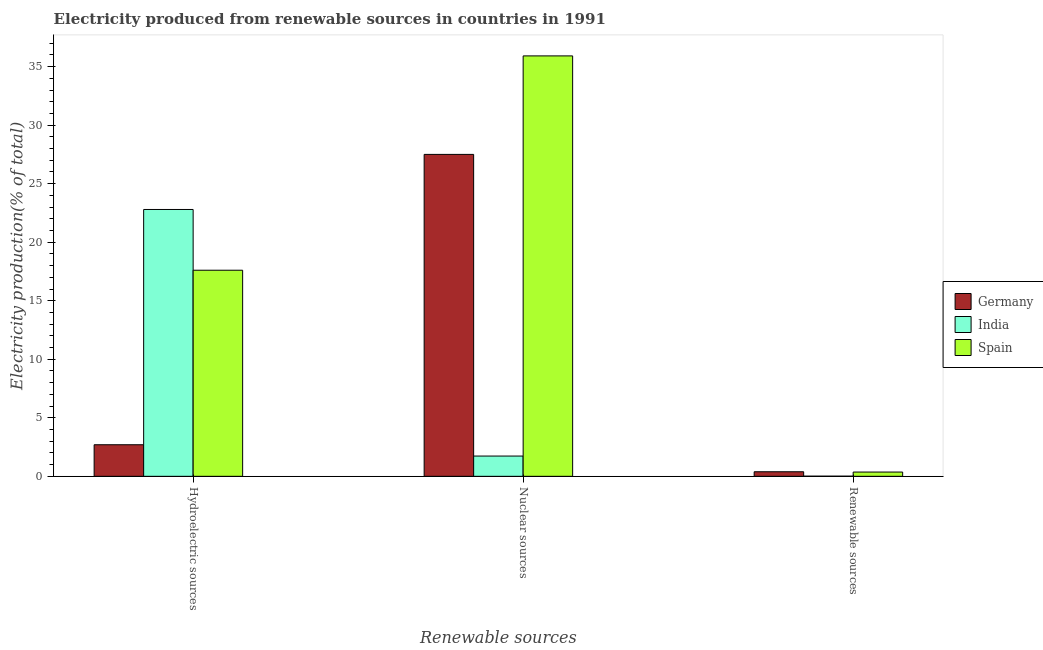Are the number of bars on each tick of the X-axis equal?
Provide a succinct answer. Yes. How many bars are there on the 1st tick from the left?
Your response must be concise. 3. How many bars are there on the 1st tick from the right?
Your answer should be compact. 3. What is the label of the 2nd group of bars from the left?
Make the answer very short. Nuclear sources. What is the percentage of electricity produced by nuclear sources in Spain?
Your answer should be compact. 35.91. Across all countries, what is the maximum percentage of electricity produced by renewable sources?
Provide a short and direct response. 0.39. Across all countries, what is the minimum percentage of electricity produced by hydroelectric sources?
Give a very brief answer. 2.7. In which country was the percentage of electricity produced by nuclear sources maximum?
Give a very brief answer. Spain. In which country was the percentage of electricity produced by hydroelectric sources minimum?
Provide a short and direct response. Germany. What is the total percentage of electricity produced by renewable sources in the graph?
Your answer should be very brief. 0.77. What is the difference between the percentage of electricity produced by nuclear sources in India and that in Spain?
Your answer should be very brief. -34.18. What is the difference between the percentage of electricity produced by nuclear sources in India and the percentage of electricity produced by hydroelectric sources in Germany?
Offer a terse response. -0.97. What is the average percentage of electricity produced by nuclear sources per country?
Your answer should be very brief. 21.72. What is the difference between the percentage of electricity produced by nuclear sources and percentage of electricity produced by renewable sources in Germany?
Provide a succinct answer. 27.11. What is the ratio of the percentage of electricity produced by hydroelectric sources in Germany to that in Spain?
Offer a terse response. 0.15. What is the difference between the highest and the second highest percentage of electricity produced by nuclear sources?
Make the answer very short. 8.41. What is the difference between the highest and the lowest percentage of electricity produced by renewable sources?
Your answer should be very brief. 0.38. Is the sum of the percentage of electricity produced by hydroelectric sources in Spain and Germany greater than the maximum percentage of electricity produced by nuclear sources across all countries?
Ensure brevity in your answer.  No. What does the 3rd bar from the left in Hydroelectric sources represents?
Your response must be concise. Spain. Are all the bars in the graph horizontal?
Your answer should be compact. No. How many legend labels are there?
Offer a very short reply. 3. What is the title of the graph?
Ensure brevity in your answer.  Electricity produced from renewable sources in countries in 1991. What is the label or title of the X-axis?
Give a very brief answer. Renewable sources. What is the Electricity production(% of total) of Germany in Hydroelectric sources?
Your answer should be very brief. 2.7. What is the Electricity production(% of total) of India in Hydroelectric sources?
Offer a very short reply. 22.8. What is the Electricity production(% of total) in Spain in Hydroelectric sources?
Your response must be concise. 17.61. What is the Electricity production(% of total) in Germany in Nuclear sources?
Make the answer very short. 27.5. What is the Electricity production(% of total) in India in Nuclear sources?
Offer a terse response. 1.73. What is the Electricity production(% of total) in Spain in Nuclear sources?
Your answer should be very brief. 35.91. What is the Electricity production(% of total) of Germany in Renewable sources?
Your answer should be very brief. 0.39. What is the Electricity production(% of total) in India in Renewable sources?
Give a very brief answer. 0.01. What is the Electricity production(% of total) in Spain in Renewable sources?
Your response must be concise. 0.36. Across all Renewable sources, what is the maximum Electricity production(% of total) in Germany?
Make the answer very short. 27.5. Across all Renewable sources, what is the maximum Electricity production(% of total) of India?
Make the answer very short. 22.8. Across all Renewable sources, what is the maximum Electricity production(% of total) of Spain?
Your answer should be compact. 35.91. Across all Renewable sources, what is the minimum Electricity production(% of total) of Germany?
Your answer should be very brief. 0.39. Across all Renewable sources, what is the minimum Electricity production(% of total) in India?
Offer a terse response. 0.01. Across all Renewable sources, what is the minimum Electricity production(% of total) in Spain?
Give a very brief answer. 0.36. What is the total Electricity production(% of total) of Germany in the graph?
Provide a succinct answer. 30.59. What is the total Electricity production(% of total) in India in the graph?
Offer a very short reply. 24.54. What is the total Electricity production(% of total) of Spain in the graph?
Your response must be concise. 53.89. What is the difference between the Electricity production(% of total) of Germany in Hydroelectric sources and that in Nuclear sources?
Your response must be concise. -24.8. What is the difference between the Electricity production(% of total) in India in Hydroelectric sources and that in Nuclear sources?
Offer a terse response. 21.06. What is the difference between the Electricity production(% of total) in Spain in Hydroelectric sources and that in Nuclear sources?
Provide a short and direct response. -18.31. What is the difference between the Electricity production(% of total) of Germany in Hydroelectric sources and that in Renewable sources?
Your answer should be compact. 2.31. What is the difference between the Electricity production(% of total) in India in Hydroelectric sources and that in Renewable sources?
Provide a succinct answer. 22.78. What is the difference between the Electricity production(% of total) in Spain in Hydroelectric sources and that in Renewable sources?
Provide a succinct answer. 17.24. What is the difference between the Electricity production(% of total) in Germany in Nuclear sources and that in Renewable sources?
Provide a succinct answer. 27.11. What is the difference between the Electricity production(% of total) in India in Nuclear sources and that in Renewable sources?
Your answer should be very brief. 1.72. What is the difference between the Electricity production(% of total) in Spain in Nuclear sources and that in Renewable sources?
Offer a very short reply. 35.55. What is the difference between the Electricity production(% of total) of Germany in Hydroelectric sources and the Electricity production(% of total) of India in Nuclear sources?
Your answer should be compact. 0.97. What is the difference between the Electricity production(% of total) in Germany in Hydroelectric sources and the Electricity production(% of total) in Spain in Nuclear sources?
Keep it short and to the point. -33.22. What is the difference between the Electricity production(% of total) in India in Hydroelectric sources and the Electricity production(% of total) in Spain in Nuclear sources?
Make the answer very short. -13.12. What is the difference between the Electricity production(% of total) in Germany in Hydroelectric sources and the Electricity production(% of total) in India in Renewable sources?
Your response must be concise. 2.69. What is the difference between the Electricity production(% of total) in Germany in Hydroelectric sources and the Electricity production(% of total) in Spain in Renewable sources?
Provide a succinct answer. 2.33. What is the difference between the Electricity production(% of total) of India in Hydroelectric sources and the Electricity production(% of total) of Spain in Renewable sources?
Provide a succinct answer. 22.43. What is the difference between the Electricity production(% of total) in Germany in Nuclear sources and the Electricity production(% of total) in India in Renewable sources?
Ensure brevity in your answer.  27.49. What is the difference between the Electricity production(% of total) in Germany in Nuclear sources and the Electricity production(% of total) in Spain in Renewable sources?
Offer a very short reply. 27.14. What is the difference between the Electricity production(% of total) of India in Nuclear sources and the Electricity production(% of total) of Spain in Renewable sources?
Your response must be concise. 1.37. What is the average Electricity production(% of total) in Germany per Renewable sources?
Provide a succinct answer. 10.2. What is the average Electricity production(% of total) in India per Renewable sources?
Your response must be concise. 8.18. What is the average Electricity production(% of total) in Spain per Renewable sources?
Offer a very short reply. 17.96. What is the difference between the Electricity production(% of total) of Germany and Electricity production(% of total) of India in Hydroelectric sources?
Make the answer very short. -20.1. What is the difference between the Electricity production(% of total) in Germany and Electricity production(% of total) in Spain in Hydroelectric sources?
Your answer should be very brief. -14.91. What is the difference between the Electricity production(% of total) in India and Electricity production(% of total) in Spain in Hydroelectric sources?
Your answer should be very brief. 5.19. What is the difference between the Electricity production(% of total) in Germany and Electricity production(% of total) in India in Nuclear sources?
Keep it short and to the point. 25.77. What is the difference between the Electricity production(% of total) of Germany and Electricity production(% of total) of Spain in Nuclear sources?
Provide a succinct answer. -8.41. What is the difference between the Electricity production(% of total) in India and Electricity production(% of total) in Spain in Nuclear sources?
Your answer should be very brief. -34.18. What is the difference between the Electricity production(% of total) in Germany and Electricity production(% of total) in India in Renewable sources?
Give a very brief answer. 0.38. What is the difference between the Electricity production(% of total) in Germany and Electricity production(% of total) in Spain in Renewable sources?
Provide a short and direct response. 0.03. What is the difference between the Electricity production(% of total) in India and Electricity production(% of total) in Spain in Renewable sources?
Offer a terse response. -0.35. What is the ratio of the Electricity production(% of total) in Germany in Hydroelectric sources to that in Nuclear sources?
Give a very brief answer. 0.1. What is the ratio of the Electricity production(% of total) in India in Hydroelectric sources to that in Nuclear sources?
Offer a very short reply. 13.17. What is the ratio of the Electricity production(% of total) in Spain in Hydroelectric sources to that in Nuclear sources?
Offer a terse response. 0.49. What is the ratio of the Electricity production(% of total) of Germany in Hydroelectric sources to that in Renewable sources?
Provide a succinct answer. 6.92. What is the ratio of the Electricity production(% of total) in India in Hydroelectric sources to that in Renewable sources?
Ensure brevity in your answer.  1866.03. What is the ratio of the Electricity production(% of total) in Spain in Hydroelectric sources to that in Renewable sources?
Provide a succinct answer. 48.31. What is the ratio of the Electricity production(% of total) in Germany in Nuclear sources to that in Renewable sources?
Offer a very short reply. 70.51. What is the ratio of the Electricity production(% of total) in India in Nuclear sources to that in Renewable sources?
Ensure brevity in your answer.  141.67. What is the ratio of the Electricity production(% of total) in Spain in Nuclear sources to that in Renewable sources?
Your response must be concise. 98.54. What is the difference between the highest and the second highest Electricity production(% of total) in Germany?
Ensure brevity in your answer.  24.8. What is the difference between the highest and the second highest Electricity production(% of total) in India?
Your response must be concise. 21.06. What is the difference between the highest and the second highest Electricity production(% of total) of Spain?
Give a very brief answer. 18.31. What is the difference between the highest and the lowest Electricity production(% of total) of Germany?
Ensure brevity in your answer.  27.11. What is the difference between the highest and the lowest Electricity production(% of total) of India?
Give a very brief answer. 22.78. What is the difference between the highest and the lowest Electricity production(% of total) in Spain?
Your answer should be very brief. 35.55. 